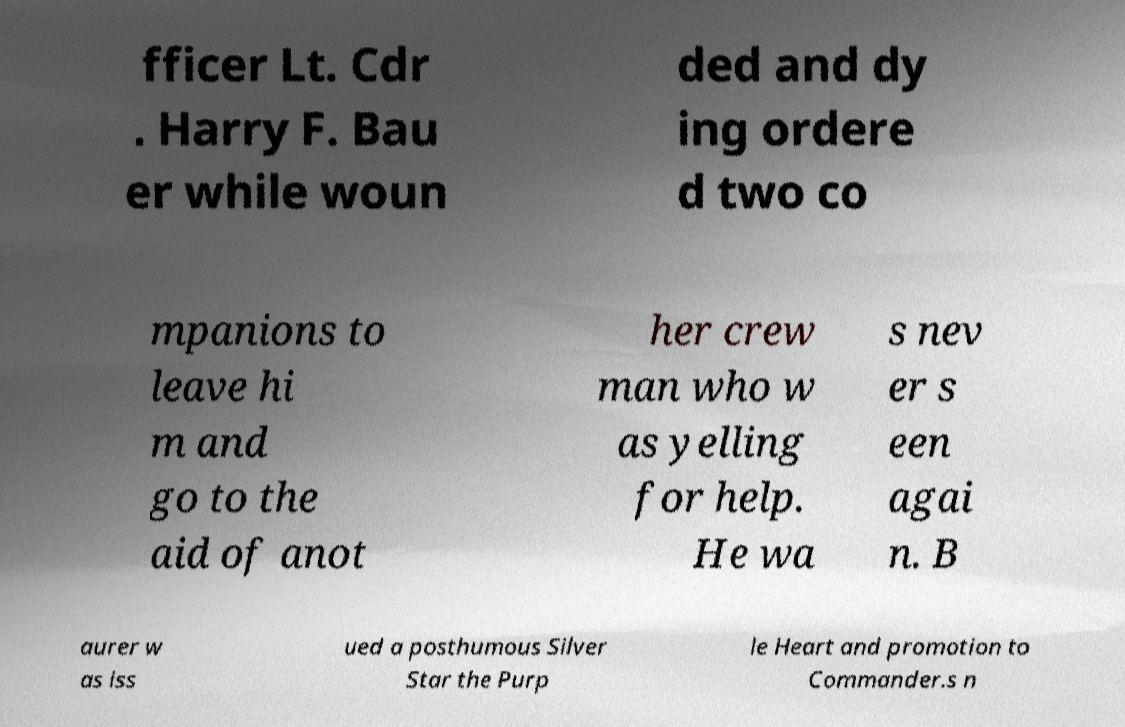There's text embedded in this image that I need extracted. Can you transcribe it verbatim? fficer Lt. Cdr . Harry F. Bau er while woun ded and dy ing ordere d two co mpanions to leave hi m and go to the aid of anot her crew man who w as yelling for help. He wa s nev er s een agai n. B aurer w as iss ued a posthumous Silver Star the Purp le Heart and promotion to Commander.s n 